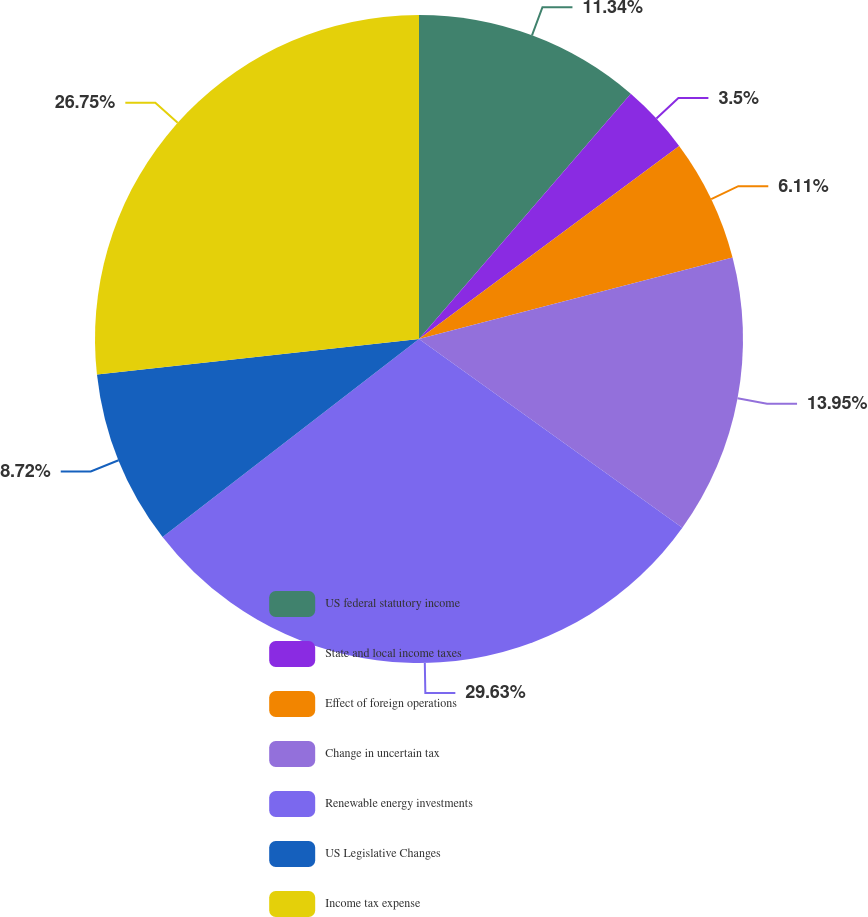<chart> <loc_0><loc_0><loc_500><loc_500><pie_chart><fcel>US federal statutory income<fcel>State and local income taxes<fcel>Effect of foreign operations<fcel>Change in uncertain tax<fcel>Renewable energy investments<fcel>US Legislative Changes<fcel>Income tax expense<nl><fcel>11.34%<fcel>3.5%<fcel>6.11%<fcel>13.95%<fcel>29.64%<fcel>8.72%<fcel>26.75%<nl></chart> 